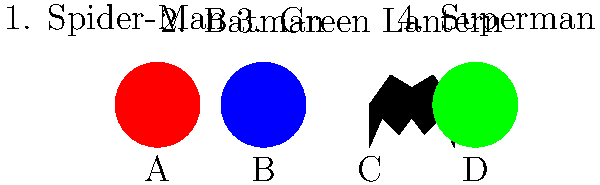Match the superhero logos (A, B, C, D) with their corresponding characters (1, 2, 3, 4). Which pairing is correct? To solve this visual challenge, we need to analyze each logo and match it with the correct superhero:

1. Logo A: A red circle. This is the iconic symbol of Spider-Man, often seen on his costume.
2. Logo B: A blue circle. This represents Superman's emblem, which is typically a red "S" on a blue background.
3. Logo C: A black bat silhouette. This is unmistakably Batman's symbol, used on his costume and as a signal.
4. Logo D: A green circle. This corresponds to the Green Lantern's power ring and emblem.

Matching these logos to the characters:
- A (red circle) matches with 1 (Spider-Man)
- B (blue circle) matches with 4 (Superman)
- C (bat symbol) matches with 2 (Batman)
- D (green circle) matches with 3 (Green Lantern)

Therefore, the correct pairing is C2: Batman's logo (C) matched with Batman (2).
Answer: C2 